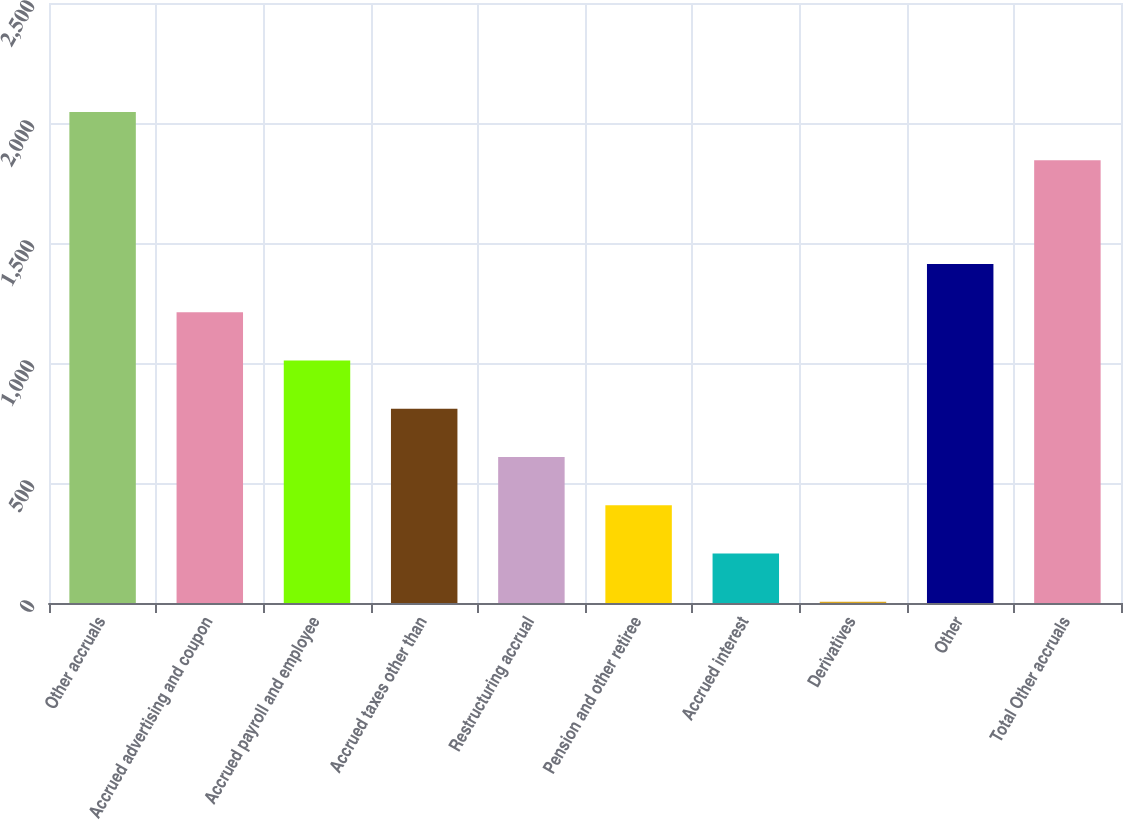<chart> <loc_0><loc_0><loc_500><loc_500><bar_chart><fcel>Other accruals<fcel>Accrued advertising and coupon<fcel>Accrued payroll and employee<fcel>Accrued taxes other than<fcel>Restructuring accrual<fcel>Pension and other retiree<fcel>Accrued interest<fcel>Derivatives<fcel>Other<fcel>Total Other accruals<nl><fcel>2046<fcel>1211<fcel>1010<fcel>809<fcel>608<fcel>407<fcel>206<fcel>5<fcel>1412<fcel>1845<nl></chart> 